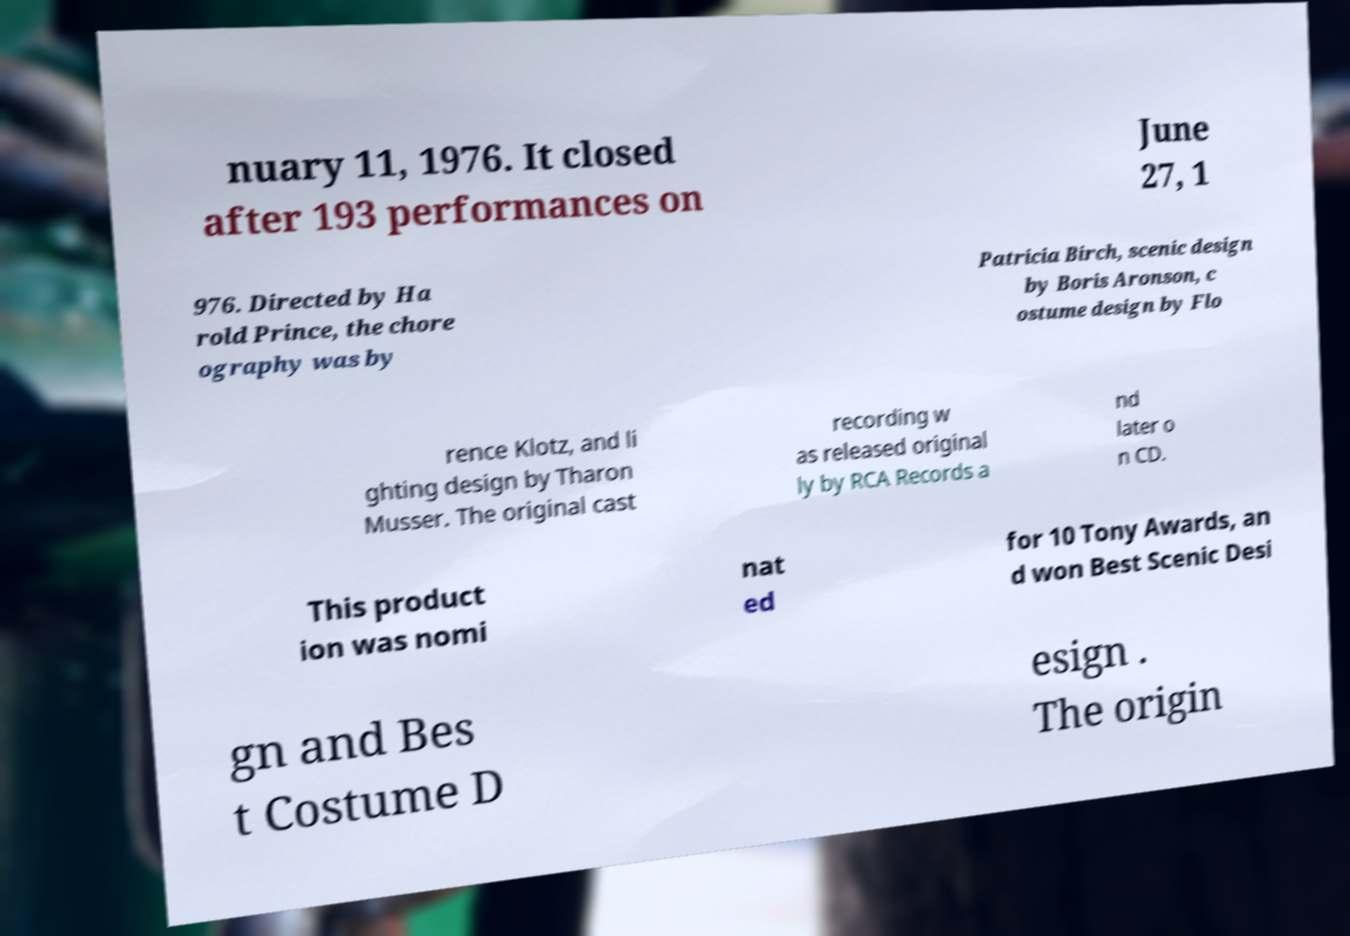Can you accurately transcribe the text from the provided image for me? nuary 11, 1976. It closed after 193 performances on June 27, 1 976. Directed by Ha rold Prince, the chore ography was by Patricia Birch, scenic design by Boris Aronson, c ostume design by Flo rence Klotz, and li ghting design by Tharon Musser. The original cast recording w as released original ly by RCA Records a nd later o n CD. This product ion was nomi nat ed for 10 Tony Awards, an d won Best Scenic Desi gn and Bes t Costume D esign . The origin 